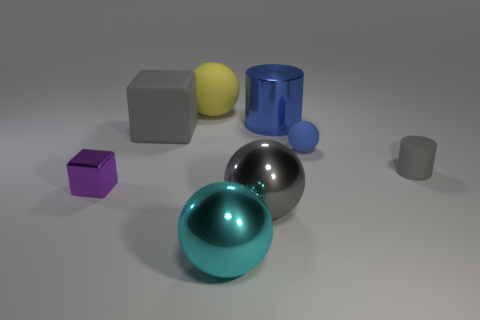Add 2 big blocks. How many objects exist? 10 Subtract all blocks. How many objects are left? 6 Add 4 blue rubber balls. How many blue rubber balls are left? 5 Add 3 yellow matte things. How many yellow matte things exist? 4 Subtract 0 red spheres. How many objects are left? 8 Subtract all yellow objects. Subtract all gray matte objects. How many objects are left? 5 